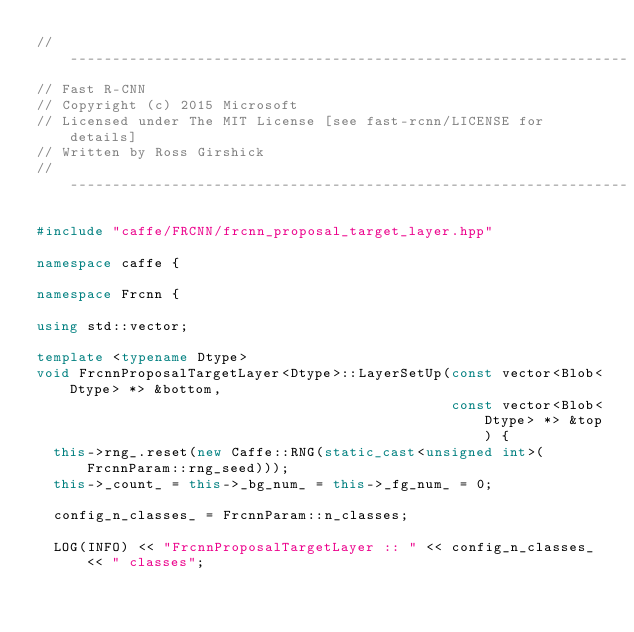<code> <loc_0><loc_0><loc_500><loc_500><_C++_>// ------------------------------------------------------------------
// Fast R-CNN
// Copyright (c) 2015 Microsoft
// Licensed under The MIT License [see fast-rcnn/LICENSE for details]
// Written by Ross Girshick
// ------------------------------------------------------------------

#include "caffe/FRCNN/frcnn_proposal_target_layer.hpp"

namespace caffe {

namespace Frcnn {

using std::vector;

template <typename Dtype>
void FrcnnProposalTargetLayer<Dtype>::LayerSetUp(const vector<Blob<Dtype> *> &bottom,
                                                 const vector<Blob<Dtype> *> &top) {
  this->rng_.reset(new Caffe::RNG(static_cast<unsigned int>(FrcnnParam::rng_seed)));
  this->_count_ = this->_bg_num_ = this->_fg_num_ = 0;

  config_n_classes_ = FrcnnParam::n_classes;

  LOG(INFO) << "FrcnnProposalTargetLayer :: " << config_n_classes_ << " classes";</code> 